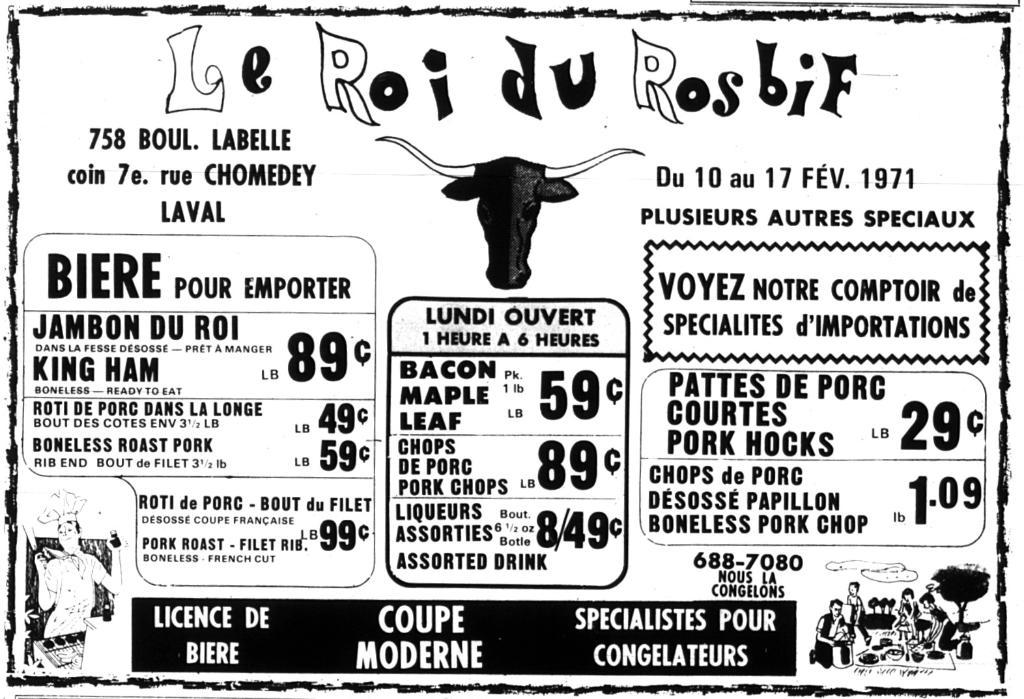What is the main subject of the image? The main subject of the image is a poster. What type of content can be found on the poster? The poster contains texts, numbers, and cartoon images. What is the color of the background on the poster? The background of the poster is white. How many hands are visible on the poster? There are no hands visible on the poster, as it contains texts, numbers, and cartoon images, but no hands. 